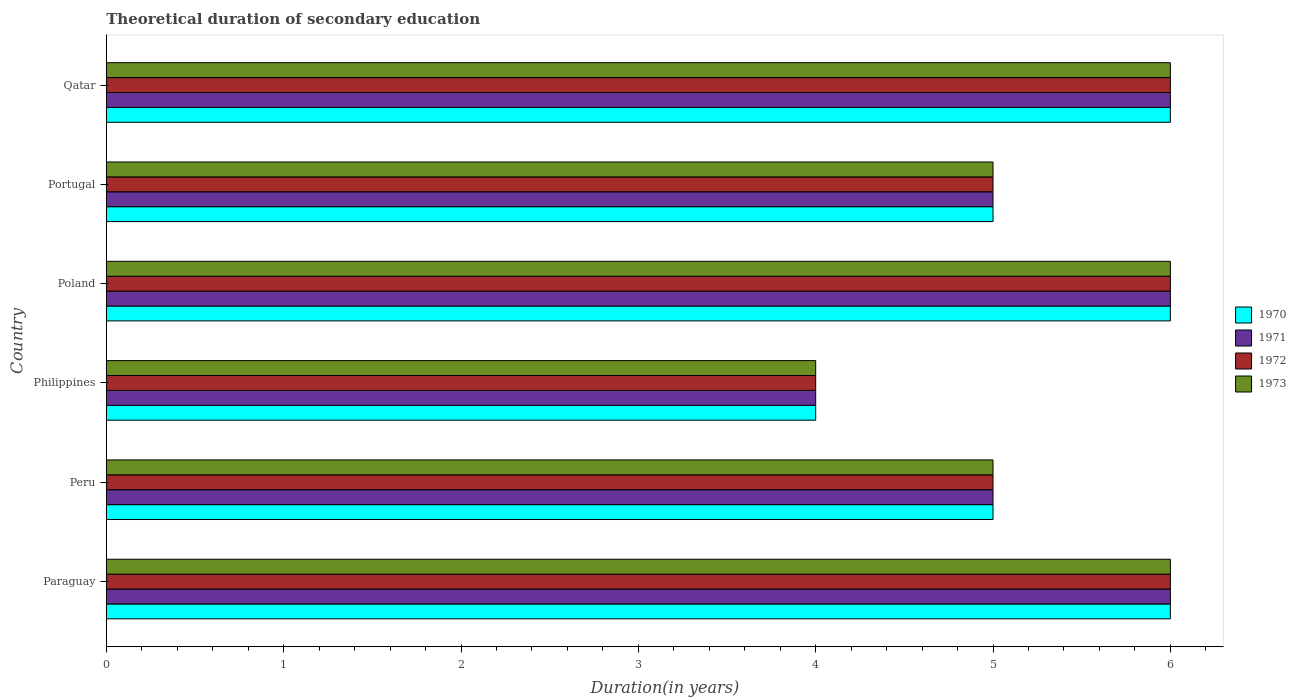How many different coloured bars are there?
Offer a very short reply. 4. Are the number of bars per tick equal to the number of legend labels?
Your answer should be compact. Yes. Are the number of bars on each tick of the Y-axis equal?
Offer a terse response. Yes. How many bars are there on the 2nd tick from the top?
Offer a terse response. 4. How many bars are there on the 3rd tick from the bottom?
Provide a succinct answer. 4. What is the label of the 5th group of bars from the top?
Give a very brief answer. Peru. Across all countries, what is the maximum total theoretical duration of secondary education in 1972?
Your response must be concise. 6. In which country was the total theoretical duration of secondary education in 1970 maximum?
Offer a terse response. Paraguay. What is the difference between the total theoretical duration of secondary education in 1971 in Paraguay and that in Poland?
Ensure brevity in your answer.  0. What is the average total theoretical duration of secondary education in 1971 per country?
Ensure brevity in your answer.  5.33. What is the difference between the total theoretical duration of secondary education in 1971 and total theoretical duration of secondary education in 1970 in Poland?
Offer a terse response. 0. What is the ratio of the total theoretical duration of secondary education in 1973 in Philippines to that in Qatar?
Offer a very short reply. 0.67. Is the total theoretical duration of secondary education in 1973 in Philippines less than that in Qatar?
Keep it short and to the point. Yes. In how many countries, is the total theoretical duration of secondary education in 1972 greater than the average total theoretical duration of secondary education in 1972 taken over all countries?
Provide a succinct answer. 3. What does the 4th bar from the bottom in Portugal represents?
Your response must be concise. 1973. Are all the bars in the graph horizontal?
Provide a succinct answer. Yes. What is the difference between two consecutive major ticks on the X-axis?
Keep it short and to the point. 1. Are the values on the major ticks of X-axis written in scientific E-notation?
Make the answer very short. No. Does the graph contain grids?
Offer a terse response. No. Where does the legend appear in the graph?
Ensure brevity in your answer.  Center right. What is the title of the graph?
Provide a succinct answer. Theoretical duration of secondary education. What is the label or title of the X-axis?
Provide a short and direct response. Duration(in years). What is the Duration(in years) in 1970 in Paraguay?
Your answer should be very brief. 6. What is the Duration(in years) in 1972 in Paraguay?
Your answer should be very brief. 6. What is the Duration(in years) of 1973 in Paraguay?
Your answer should be very brief. 6. What is the Duration(in years) of 1970 in Peru?
Your response must be concise. 5. What is the Duration(in years) in 1971 in Peru?
Your answer should be compact. 5. What is the Duration(in years) in 1973 in Peru?
Provide a succinct answer. 5. What is the Duration(in years) in 1970 in Philippines?
Give a very brief answer. 4. What is the Duration(in years) in 1971 in Philippines?
Provide a succinct answer. 4. What is the Duration(in years) of 1972 in Philippines?
Give a very brief answer. 4. What is the Duration(in years) in 1972 in Poland?
Your answer should be very brief. 6. What is the Duration(in years) of 1973 in Portugal?
Make the answer very short. 5. What is the Duration(in years) in 1973 in Qatar?
Give a very brief answer. 6. Across all countries, what is the maximum Duration(in years) in 1970?
Offer a very short reply. 6. Across all countries, what is the maximum Duration(in years) of 1972?
Provide a succinct answer. 6. Across all countries, what is the minimum Duration(in years) of 1970?
Your response must be concise. 4. Across all countries, what is the minimum Duration(in years) of 1971?
Give a very brief answer. 4. What is the total Duration(in years) of 1970 in the graph?
Your response must be concise. 32. What is the total Duration(in years) in 1971 in the graph?
Ensure brevity in your answer.  32. What is the difference between the Duration(in years) of 1970 in Paraguay and that in Peru?
Keep it short and to the point. 1. What is the difference between the Duration(in years) in 1972 in Paraguay and that in Peru?
Keep it short and to the point. 1. What is the difference between the Duration(in years) of 1973 in Paraguay and that in Peru?
Offer a very short reply. 1. What is the difference between the Duration(in years) in 1970 in Paraguay and that in Philippines?
Your answer should be very brief. 2. What is the difference between the Duration(in years) in 1972 in Paraguay and that in Philippines?
Keep it short and to the point. 2. What is the difference between the Duration(in years) in 1971 in Paraguay and that in Poland?
Keep it short and to the point. 0. What is the difference between the Duration(in years) in 1973 in Paraguay and that in Poland?
Offer a terse response. 0. What is the difference between the Duration(in years) in 1971 in Paraguay and that in Portugal?
Offer a very short reply. 1. What is the difference between the Duration(in years) of 1972 in Paraguay and that in Portugal?
Provide a short and direct response. 1. What is the difference between the Duration(in years) in 1970 in Paraguay and that in Qatar?
Your answer should be very brief. 0. What is the difference between the Duration(in years) of 1972 in Paraguay and that in Qatar?
Give a very brief answer. 0. What is the difference between the Duration(in years) in 1971 in Peru and that in Philippines?
Offer a very short reply. 1. What is the difference between the Duration(in years) in 1970 in Peru and that in Poland?
Provide a succinct answer. -1. What is the difference between the Duration(in years) of 1971 in Peru and that in Poland?
Make the answer very short. -1. What is the difference between the Duration(in years) of 1972 in Peru and that in Poland?
Ensure brevity in your answer.  -1. What is the difference between the Duration(in years) of 1970 in Peru and that in Portugal?
Provide a short and direct response. 0. What is the difference between the Duration(in years) of 1973 in Peru and that in Portugal?
Your response must be concise. 0. What is the difference between the Duration(in years) of 1970 in Peru and that in Qatar?
Your answer should be very brief. -1. What is the difference between the Duration(in years) of 1971 in Peru and that in Qatar?
Ensure brevity in your answer.  -1. What is the difference between the Duration(in years) in 1972 in Peru and that in Qatar?
Your answer should be very brief. -1. What is the difference between the Duration(in years) of 1973 in Peru and that in Qatar?
Offer a terse response. -1. What is the difference between the Duration(in years) in 1972 in Philippines and that in Poland?
Offer a very short reply. -2. What is the difference between the Duration(in years) in 1973 in Philippines and that in Poland?
Your response must be concise. -2. What is the difference between the Duration(in years) in 1970 in Philippines and that in Portugal?
Your answer should be compact. -1. What is the difference between the Duration(in years) in 1971 in Philippines and that in Portugal?
Provide a short and direct response. -1. What is the difference between the Duration(in years) in 1972 in Philippines and that in Qatar?
Offer a terse response. -2. What is the difference between the Duration(in years) in 1973 in Philippines and that in Qatar?
Give a very brief answer. -2. What is the difference between the Duration(in years) in 1970 in Poland and that in Portugal?
Make the answer very short. 1. What is the difference between the Duration(in years) of 1971 in Poland and that in Portugal?
Provide a short and direct response. 1. What is the difference between the Duration(in years) of 1973 in Poland and that in Portugal?
Offer a very short reply. 1. What is the difference between the Duration(in years) of 1970 in Portugal and that in Qatar?
Ensure brevity in your answer.  -1. What is the difference between the Duration(in years) of 1971 in Portugal and that in Qatar?
Your answer should be very brief. -1. What is the difference between the Duration(in years) in 1973 in Portugal and that in Qatar?
Offer a very short reply. -1. What is the difference between the Duration(in years) in 1970 in Paraguay and the Duration(in years) in 1973 in Peru?
Provide a succinct answer. 1. What is the difference between the Duration(in years) of 1971 in Paraguay and the Duration(in years) of 1972 in Peru?
Offer a very short reply. 1. What is the difference between the Duration(in years) in 1972 in Paraguay and the Duration(in years) in 1973 in Peru?
Keep it short and to the point. 1. What is the difference between the Duration(in years) in 1970 in Paraguay and the Duration(in years) in 1972 in Philippines?
Give a very brief answer. 2. What is the difference between the Duration(in years) of 1970 in Paraguay and the Duration(in years) of 1973 in Philippines?
Provide a short and direct response. 2. What is the difference between the Duration(in years) in 1971 in Paraguay and the Duration(in years) in 1972 in Philippines?
Provide a short and direct response. 2. What is the difference between the Duration(in years) in 1972 in Paraguay and the Duration(in years) in 1973 in Philippines?
Keep it short and to the point. 2. What is the difference between the Duration(in years) of 1970 in Paraguay and the Duration(in years) of 1971 in Poland?
Offer a terse response. 0. What is the difference between the Duration(in years) of 1970 in Paraguay and the Duration(in years) of 1972 in Poland?
Keep it short and to the point. 0. What is the difference between the Duration(in years) of 1970 in Paraguay and the Duration(in years) of 1971 in Portugal?
Provide a short and direct response. 1. What is the difference between the Duration(in years) of 1970 in Paraguay and the Duration(in years) of 1973 in Portugal?
Provide a short and direct response. 1. What is the difference between the Duration(in years) in 1971 in Paraguay and the Duration(in years) in 1972 in Portugal?
Offer a very short reply. 1. What is the difference between the Duration(in years) in 1971 in Paraguay and the Duration(in years) in 1973 in Portugal?
Your answer should be very brief. 1. What is the difference between the Duration(in years) in 1972 in Paraguay and the Duration(in years) in 1973 in Portugal?
Give a very brief answer. 1. What is the difference between the Duration(in years) in 1970 in Paraguay and the Duration(in years) in 1973 in Qatar?
Keep it short and to the point. 0. What is the difference between the Duration(in years) of 1972 in Paraguay and the Duration(in years) of 1973 in Qatar?
Provide a short and direct response. 0. What is the difference between the Duration(in years) in 1970 in Peru and the Duration(in years) in 1972 in Philippines?
Make the answer very short. 1. What is the difference between the Duration(in years) of 1972 in Peru and the Duration(in years) of 1973 in Philippines?
Your answer should be very brief. 1. What is the difference between the Duration(in years) in 1970 in Peru and the Duration(in years) in 1973 in Poland?
Give a very brief answer. -1. What is the difference between the Duration(in years) of 1971 in Peru and the Duration(in years) of 1972 in Poland?
Give a very brief answer. -1. What is the difference between the Duration(in years) in 1970 in Peru and the Duration(in years) in 1972 in Portugal?
Make the answer very short. 0. What is the difference between the Duration(in years) of 1971 in Peru and the Duration(in years) of 1973 in Portugal?
Offer a very short reply. 0. What is the difference between the Duration(in years) of 1970 in Peru and the Duration(in years) of 1972 in Qatar?
Offer a very short reply. -1. What is the difference between the Duration(in years) in 1970 in Peru and the Duration(in years) in 1973 in Qatar?
Provide a short and direct response. -1. What is the difference between the Duration(in years) in 1972 in Peru and the Duration(in years) in 1973 in Qatar?
Your answer should be very brief. -1. What is the difference between the Duration(in years) of 1970 in Philippines and the Duration(in years) of 1971 in Poland?
Your response must be concise. -2. What is the difference between the Duration(in years) of 1971 in Philippines and the Duration(in years) of 1972 in Poland?
Make the answer very short. -2. What is the difference between the Duration(in years) of 1971 in Philippines and the Duration(in years) of 1973 in Poland?
Ensure brevity in your answer.  -2. What is the difference between the Duration(in years) in 1970 in Philippines and the Duration(in years) in 1971 in Portugal?
Make the answer very short. -1. What is the difference between the Duration(in years) of 1970 in Philippines and the Duration(in years) of 1973 in Portugal?
Offer a very short reply. -1. What is the difference between the Duration(in years) in 1971 in Philippines and the Duration(in years) in 1972 in Portugal?
Ensure brevity in your answer.  -1. What is the difference between the Duration(in years) of 1971 in Philippines and the Duration(in years) of 1973 in Portugal?
Your answer should be very brief. -1. What is the difference between the Duration(in years) in 1972 in Philippines and the Duration(in years) in 1973 in Portugal?
Your answer should be compact. -1. What is the difference between the Duration(in years) in 1970 in Philippines and the Duration(in years) in 1972 in Qatar?
Keep it short and to the point. -2. What is the difference between the Duration(in years) of 1971 in Philippines and the Duration(in years) of 1972 in Qatar?
Your answer should be very brief. -2. What is the difference between the Duration(in years) of 1970 in Poland and the Duration(in years) of 1972 in Portugal?
Provide a succinct answer. 1. What is the difference between the Duration(in years) in 1971 in Poland and the Duration(in years) in 1973 in Portugal?
Your answer should be very brief. 1. What is the difference between the Duration(in years) in 1972 in Poland and the Duration(in years) in 1973 in Portugal?
Offer a very short reply. 1. What is the difference between the Duration(in years) of 1970 in Poland and the Duration(in years) of 1972 in Qatar?
Your answer should be very brief. 0. What is the difference between the Duration(in years) in 1971 in Poland and the Duration(in years) in 1972 in Qatar?
Offer a terse response. 0. What is the difference between the Duration(in years) of 1970 in Portugal and the Duration(in years) of 1973 in Qatar?
Offer a very short reply. -1. What is the difference between the Duration(in years) in 1971 in Portugal and the Duration(in years) in 1972 in Qatar?
Your answer should be compact. -1. What is the difference between the Duration(in years) in 1972 in Portugal and the Duration(in years) in 1973 in Qatar?
Provide a succinct answer. -1. What is the average Duration(in years) in 1970 per country?
Provide a succinct answer. 5.33. What is the average Duration(in years) of 1971 per country?
Your answer should be very brief. 5.33. What is the average Duration(in years) of 1972 per country?
Offer a very short reply. 5.33. What is the average Duration(in years) of 1973 per country?
Keep it short and to the point. 5.33. What is the difference between the Duration(in years) of 1971 and Duration(in years) of 1972 in Paraguay?
Provide a short and direct response. 0. What is the difference between the Duration(in years) of 1971 and Duration(in years) of 1973 in Paraguay?
Your answer should be very brief. 0. What is the difference between the Duration(in years) of 1972 and Duration(in years) of 1973 in Paraguay?
Keep it short and to the point. 0. What is the difference between the Duration(in years) of 1970 and Duration(in years) of 1972 in Peru?
Give a very brief answer. 0. What is the difference between the Duration(in years) in 1971 and Duration(in years) in 1973 in Peru?
Make the answer very short. 0. What is the difference between the Duration(in years) of 1970 and Duration(in years) of 1971 in Philippines?
Ensure brevity in your answer.  0. What is the difference between the Duration(in years) in 1970 and Duration(in years) in 1972 in Philippines?
Offer a terse response. 0. What is the difference between the Duration(in years) in 1971 and Duration(in years) in 1972 in Philippines?
Your response must be concise. 0. What is the difference between the Duration(in years) of 1970 and Duration(in years) of 1973 in Poland?
Offer a very short reply. 0. What is the difference between the Duration(in years) of 1971 and Duration(in years) of 1972 in Portugal?
Offer a very short reply. 0. What is the difference between the Duration(in years) of 1972 and Duration(in years) of 1973 in Portugal?
Your response must be concise. 0. What is the difference between the Duration(in years) in 1970 and Duration(in years) in 1971 in Qatar?
Your answer should be compact. 0. What is the difference between the Duration(in years) of 1970 and Duration(in years) of 1972 in Qatar?
Your answer should be compact. 0. What is the difference between the Duration(in years) of 1971 and Duration(in years) of 1972 in Qatar?
Your answer should be very brief. 0. What is the difference between the Duration(in years) of 1971 and Duration(in years) of 1973 in Qatar?
Make the answer very short. 0. What is the ratio of the Duration(in years) of 1971 in Paraguay to that in Peru?
Your response must be concise. 1.2. What is the ratio of the Duration(in years) of 1972 in Paraguay to that in Peru?
Give a very brief answer. 1.2. What is the ratio of the Duration(in years) in 1971 in Paraguay to that in Philippines?
Keep it short and to the point. 1.5. What is the ratio of the Duration(in years) in 1972 in Paraguay to that in Philippines?
Your response must be concise. 1.5. What is the ratio of the Duration(in years) in 1973 in Paraguay to that in Philippines?
Make the answer very short. 1.5. What is the ratio of the Duration(in years) in 1970 in Paraguay to that in Poland?
Offer a very short reply. 1. What is the ratio of the Duration(in years) in 1971 in Paraguay to that in Poland?
Give a very brief answer. 1. What is the ratio of the Duration(in years) in 1973 in Paraguay to that in Poland?
Offer a terse response. 1. What is the ratio of the Duration(in years) in 1971 in Paraguay to that in Portugal?
Offer a very short reply. 1.2. What is the ratio of the Duration(in years) of 1973 in Paraguay to that in Portugal?
Your answer should be compact. 1.2. What is the ratio of the Duration(in years) in 1973 in Paraguay to that in Qatar?
Provide a succinct answer. 1. What is the ratio of the Duration(in years) of 1971 in Peru to that in Philippines?
Your response must be concise. 1.25. What is the ratio of the Duration(in years) in 1972 in Peru to that in Philippines?
Provide a short and direct response. 1.25. What is the ratio of the Duration(in years) of 1971 in Peru to that in Poland?
Make the answer very short. 0.83. What is the ratio of the Duration(in years) in 1973 in Peru to that in Poland?
Make the answer very short. 0.83. What is the ratio of the Duration(in years) in 1970 in Peru to that in Portugal?
Your answer should be very brief. 1. What is the ratio of the Duration(in years) of 1972 in Peru to that in Qatar?
Keep it short and to the point. 0.83. What is the ratio of the Duration(in years) in 1971 in Philippines to that in Poland?
Provide a succinct answer. 0.67. What is the ratio of the Duration(in years) of 1973 in Philippines to that in Poland?
Your answer should be compact. 0.67. What is the ratio of the Duration(in years) of 1971 in Philippines to that in Portugal?
Offer a terse response. 0.8. What is the ratio of the Duration(in years) of 1973 in Philippines to that in Portugal?
Provide a succinct answer. 0.8. What is the ratio of the Duration(in years) in 1971 in Philippines to that in Qatar?
Your answer should be very brief. 0.67. What is the ratio of the Duration(in years) of 1973 in Philippines to that in Qatar?
Make the answer very short. 0.67. What is the ratio of the Duration(in years) of 1973 in Poland to that in Portugal?
Make the answer very short. 1.2. What is the ratio of the Duration(in years) of 1971 in Poland to that in Qatar?
Your answer should be very brief. 1. What is the ratio of the Duration(in years) in 1972 in Poland to that in Qatar?
Keep it short and to the point. 1. What is the ratio of the Duration(in years) in 1970 in Portugal to that in Qatar?
Give a very brief answer. 0.83. What is the ratio of the Duration(in years) in 1973 in Portugal to that in Qatar?
Keep it short and to the point. 0.83. What is the difference between the highest and the second highest Duration(in years) of 1973?
Provide a succinct answer. 0. What is the difference between the highest and the lowest Duration(in years) in 1970?
Provide a short and direct response. 2. What is the difference between the highest and the lowest Duration(in years) in 1972?
Offer a terse response. 2. What is the difference between the highest and the lowest Duration(in years) in 1973?
Make the answer very short. 2. 